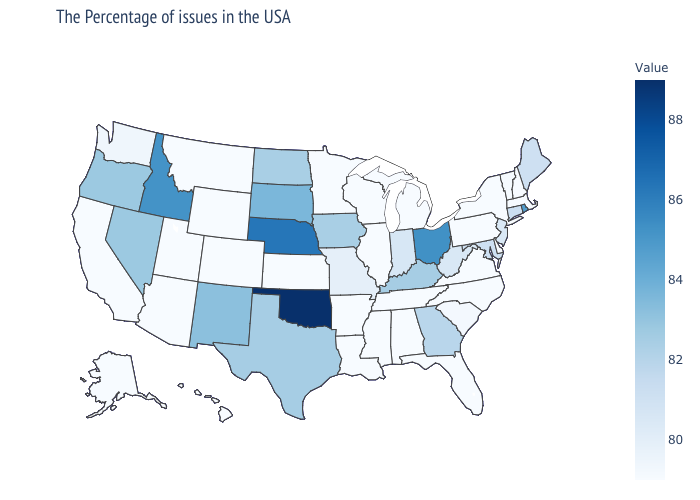Does Massachusetts have the highest value in the Northeast?
Answer briefly. No. Does Illinois have the highest value in the MidWest?
Concise answer only. No. Among the states that border Idaho , does Montana have the lowest value?
Give a very brief answer. Yes. Which states hav the highest value in the Northeast?
Be succinct. Rhode Island. Among the states that border Iowa , which have the lowest value?
Quick response, please. Wisconsin, Illinois, Minnesota. 